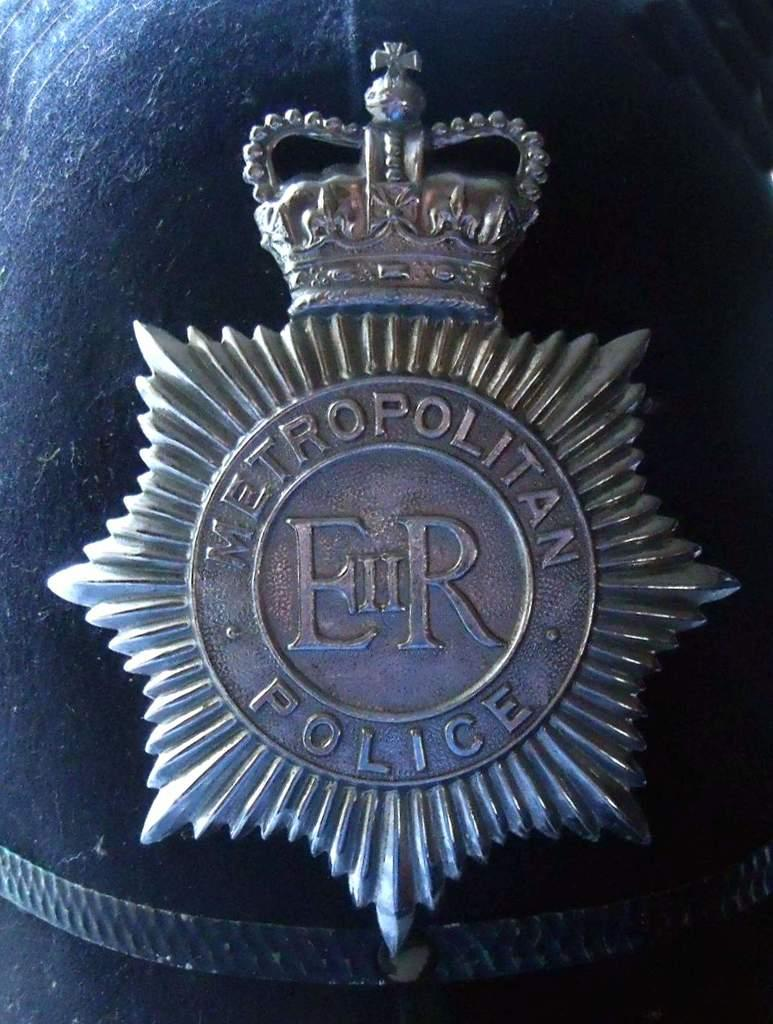<image>
Create a compact narrative representing the image presented. A metropolitan police emblem made of metal sitting upon something. 